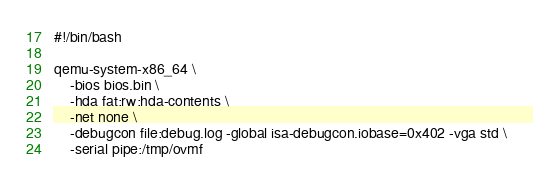Convert code to text. <code><loc_0><loc_0><loc_500><loc_500><_Bash_>#!/bin/bash

qemu-system-x86_64 \
	-bios bios.bin \
	-hda fat:rw:hda-contents \
	-net none \
	-debugcon file:debug.log -global isa-debugcon.iobase=0x402 -vga std \
	-serial pipe:/tmp/ovmf
</code> 